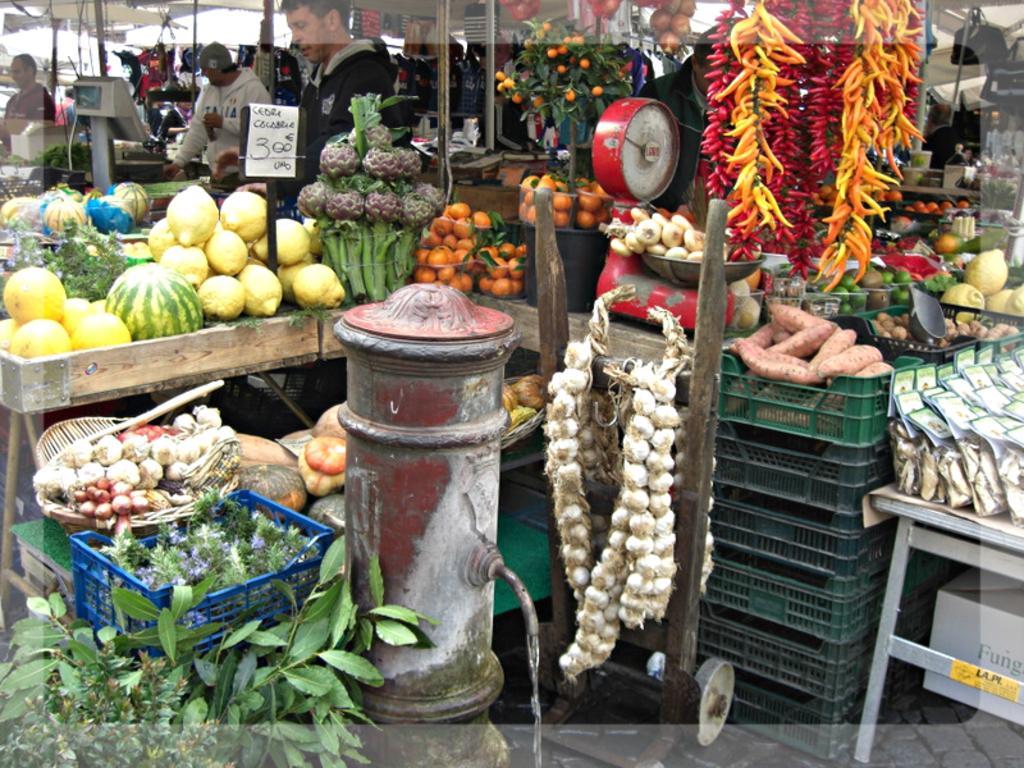Can you describe this image briefly? Picture of a vegetable market. In this image we can see vegetables, fruits, price tags, weighing machine, hydrant, baskets, people, rods and things. 